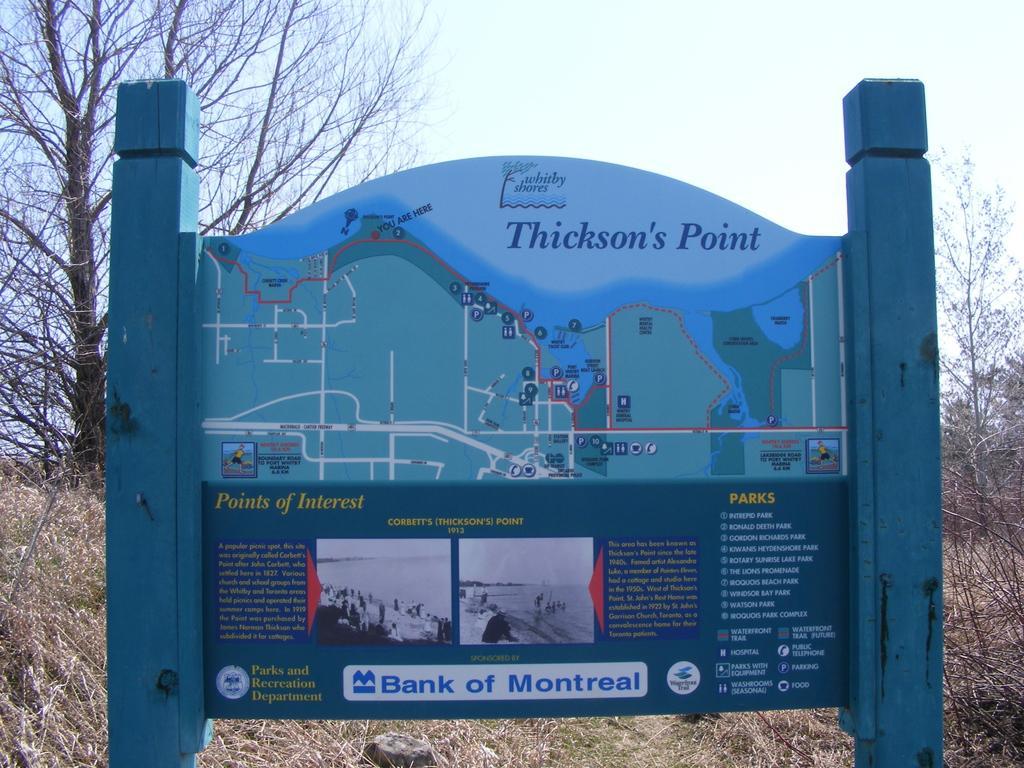Could you give a brief overview of what you see in this image? In this image we can see a board. We can see a map, few photos and some text on the board. There are few trees in the image. There are many plants in the image. We can see the sky in the image. 